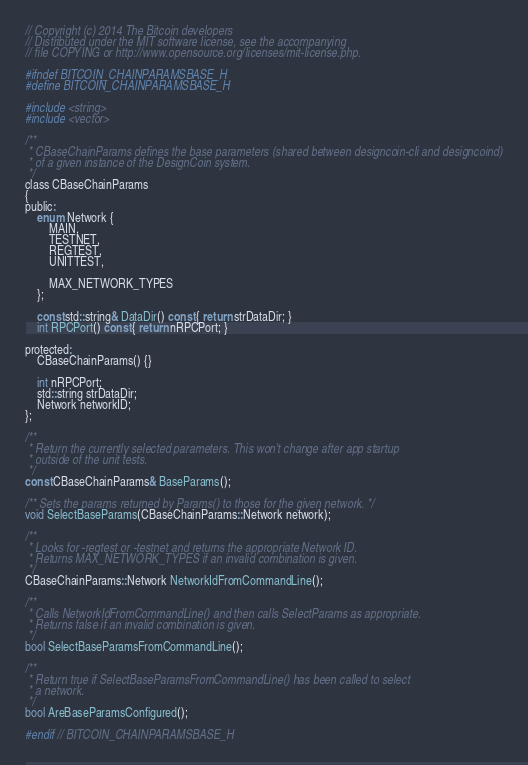<code> <loc_0><loc_0><loc_500><loc_500><_C_>// Copyright (c) 2014 The Bitcoin developers
// Distributed under the MIT software license, see the accompanying
// file COPYING or http://www.opensource.org/licenses/mit-license.php.

#ifndef BITCOIN_CHAINPARAMSBASE_H
#define BITCOIN_CHAINPARAMSBASE_H

#include <string>
#include <vector>

/**
 * CBaseChainParams defines the base parameters (shared between designcoin-cli and designcoind)
 * of a given instance of the DesignCoin system.
 */
class CBaseChainParams
{
public:
    enum Network {
        MAIN,
        TESTNET,
        REGTEST,
        UNITTEST,

        MAX_NETWORK_TYPES
    };

    const std::string& DataDir() const { return strDataDir; }
    int RPCPort() const { return nRPCPort; }

protected:
    CBaseChainParams() {}

    int nRPCPort;
    std::string strDataDir;
    Network networkID;
};

/**
 * Return the currently selected parameters. This won't change after app startup
 * outside of the unit tests.
 */
const CBaseChainParams& BaseParams();

/** Sets the params returned by Params() to those for the given network. */
void SelectBaseParams(CBaseChainParams::Network network);

/**
 * Looks for -regtest or -testnet and returns the appropriate Network ID.
 * Returns MAX_NETWORK_TYPES if an invalid combination is given.
 */
CBaseChainParams::Network NetworkIdFromCommandLine();

/**
 * Calls NetworkIdFromCommandLine() and then calls SelectParams as appropriate.
 * Returns false if an invalid combination is given.
 */
bool SelectBaseParamsFromCommandLine();

/**
 * Return true if SelectBaseParamsFromCommandLine() has been called to select
 * a network.
 */
bool AreBaseParamsConfigured();

#endif // BITCOIN_CHAINPARAMSBASE_H
</code> 